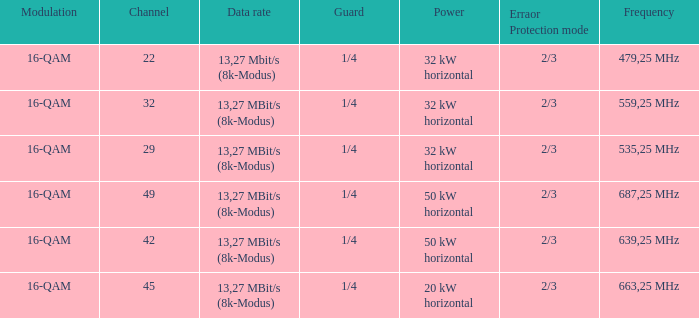On channel 32, when the power is 32 kw aligned horizontally, what is the frequency? 559,25 MHz. 